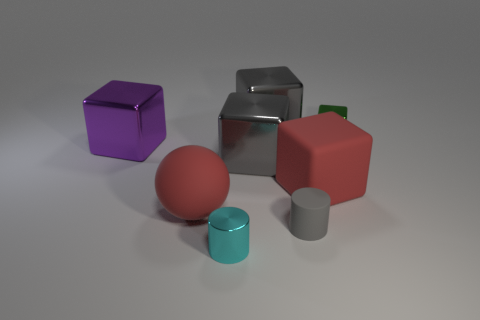What is the small thing that is in front of the large red ball and behind the cyan shiny thing made of?
Provide a succinct answer. Rubber. Is the size of the metal cube that is in front of the purple metallic thing the same as the large red rubber ball?
Keep it short and to the point. Yes. There is a big purple shiny object; what shape is it?
Keep it short and to the point. Cube. What number of tiny rubber things are the same shape as the small cyan metallic thing?
Provide a succinct answer. 1. What number of tiny shiny objects are in front of the red ball and behind the gray cylinder?
Keep it short and to the point. 0. What color is the big matte ball?
Ensure brevity in your answer.  Red. Are there any big things made of the same material as the small gray thing?
Keep it short and to the point. Yes. There is a rubber block that is left of the small metallic thing on the right side of the red cube; is there a metal thing that is on the right side of it?
Your response must be concise. Yes. Are there any blocks behind the large purple cube?
Your answer should be very brief. Yes. Is there a large metallic block of the same color as the small rubber thing?
Offer a very short reply. Yes. 